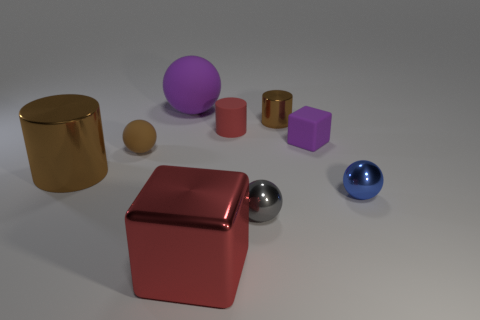Subtract all small red rubber cylinders. How many cylinders are left? 2 Subtract all cylinders. How many objects are left? 6 Subtract all red cubes. How many cubes are left? 1 Add 2 brown metallic cylinders. How many brown metallic cylinders exist? 4 Add 1 large cylinders. How many objects exist? 10 Subtract 2 brown cylinders. How many objects are left? 7 Subtract 2 spheres. How many spheres are left? 2 Subtract all red balls. Subtract all red cylinders. How many balls are left? 4 Subtract all gray balls. How many brown cylinders are left? 2 Subtract all small brown matte things. Subtract all tiny red cylinders. How many objects are left? 7 